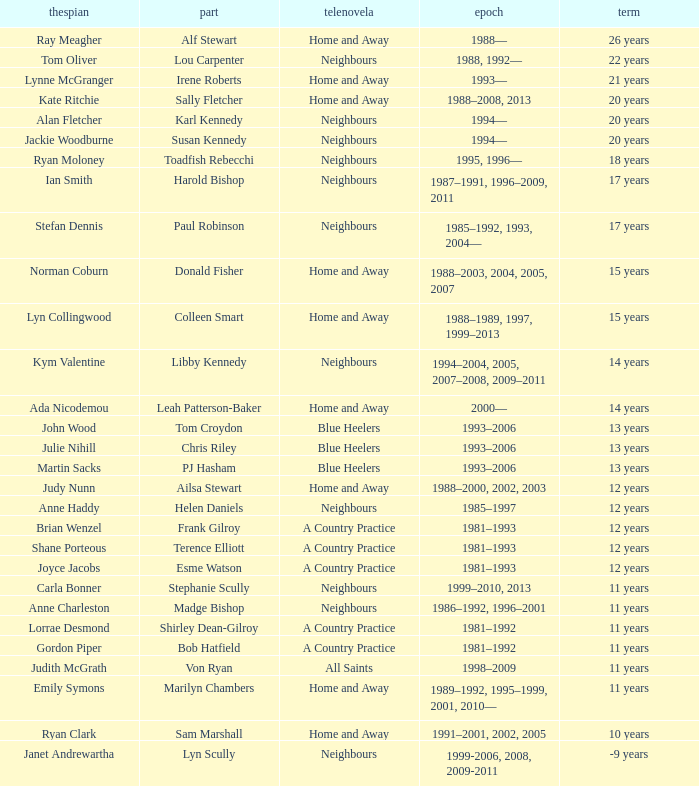What are the years when martin sacks acted in a soap opera? 1993–2006. I'm looking to parse the entire table for insights. Could you assist me with that? {'header': ['thespian', 'part', 'telenovela', 'epoch', 'term'], 'rows': [['Ray Meagher', 'Alf Stewart', 'Home and Away', '1988—', '26 years'], ['Tom Oliver', 'Lou Carpenter', 'Neighbours', '1988, 1992—', '22 years'], ['Lynne McGranger', 'Irene Roberts', 'Home and Away', '1993—', '21 years'], ['Kate Ritchie', 'Sally Fletcher', 'Home and Away', '1988–2008, 2013', '20 years'], ['Alan Fletcher', 'Karl Kennedy', 'Neighbours', '1994—', '20 years'], ['Jackie Woodburne', 'Susan Kennedy', 'Neighbours', '1994—', '20 years'], ['Ryan Moloney', 'Toadfish Rebecchi', 'Neighbours', '1995, 1996—', '18 years'], ['Ian Smith', 'Harold Bishop', 'Neighbours', '1987–1991, 1996–2009, 2011', '17 years'], ['Stefan Dennis', 'Paul Robinson', 'Neighbours', '1985–1992, 1993, 2004—', '17 years'], ['Norman Coburn', 'Donald Fisher', 'Home and Away', '1988–2003, 2004, 2005, 2007', '15 years'], ['Lyn Collingwood', 'Colleen Smart', 'Home and Away', '1988–1989, 1997, 1999–2013', '15 years'], ['Kym Valentine', 'Libby Kennedy', 'Neighbours', '1994–2004, 2005, 2007–2008, 2009–2011', '14 years'], ['Ada Nicodemou', 'Leah Patterson-Baker', 'Home and Away', '2000—', '14 years'], ['John Wood', 'Tom Croydon', 'Blue Heelers', '1993–2006', '13 years'], ['Julie Nihill', 'Chris Riley', 'Blue Heelers', '1993–2006', '13 years'], ['Martin Sacks', 'PJ Hasham', 'Blue Heelers', '1993–2006', '13 years'], ['Judy Nunn', 'Ailsa Stewart', 'Home and Away', '1988–2000, 2002, 2003', '12 years'], ['Anne Haddy', 'Helen Daniels', 'Neighbours', '1985–1997', '12 years'], ['Brian Wenzel', 'Frank Gilroy', 'A Country Practice', '1981–1993', '12 years'], ['Shane Porteous', 'Terence Elliott', 'A Country Practice', '1981–1993', '12 years'], ['Joyce Jacobs', 'Esme Watson', 'A Country Practice', '1981–1993', '12 years'], ['Carla Bonner', 'Stephanie Scully', 'Neighbours', '1999–2010, 2013', '11 years'], ['Anne Charleston', 'Madge Bishop', 'Neighbours', '1986–1992, 1996–2001', '11 years'], ['Lorrae Desmond', 'Shirley Dean-Gilroy', 'A Country Practice', '1981–1992', '11 years'], ['Gordon Piper', 'Bob Hatfield', 'A Country Practice', '1981–1992', '11 years'], ['Judith McGrath', 'Von Ryan', 'All Saints', '1998–2009', '11 years'], ['Emily Symons', 'Marilyn Chambers', 'Home and Away', '1989–1992, 1995–1999, 2001, 2010—', '11 years'], ['Ryan Clark', 'Sam Marshall', 'Home and Away', '1991–2001, 2002, 2005', '10 years'], ['Janet Andrewartha', 'Lyn Scully', 'Neighbours', '1999-2006, 2008, 2009-2011', '-9 years']]} 